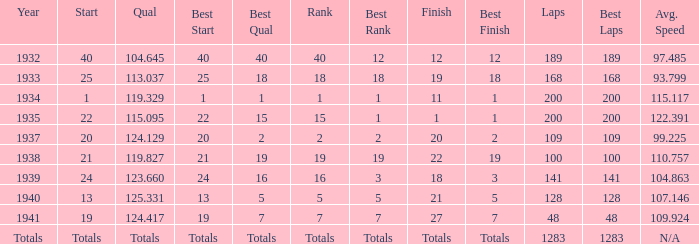What year did he start at 13? 1940.0. 